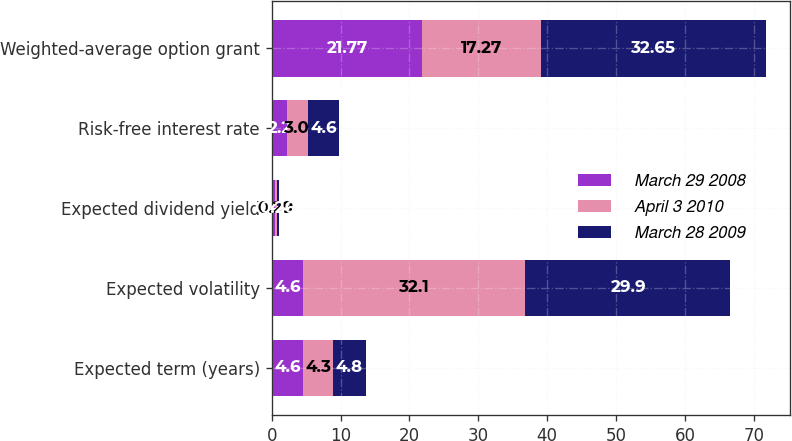Convert chart to OTSL. <chart><loc_0><loc_0><loc_500><loc_500><stacked_bar_chart><ecel><fcel>Expected term (years)<fcel>Expected volatility<fcel>Expected dividend yield<fcel>Risk-free interest rate<fcel>Weighted-average option grant<nl><fcel>March 29 2008<fcel>4.6<fcel>4.6<fcel>0.46<fcel>2.2<fcel>21.77<nl><fcel>April 3 2010<fcel>4.3<fcel>32.1<fcel>0.29<fcel>3<fcel>17.27<nl><fcel>March 28 2009<fcel>4.8<fcel>29.9<fcel>0.26<fcel>4.6<fcel>32.65<nl></chart> 